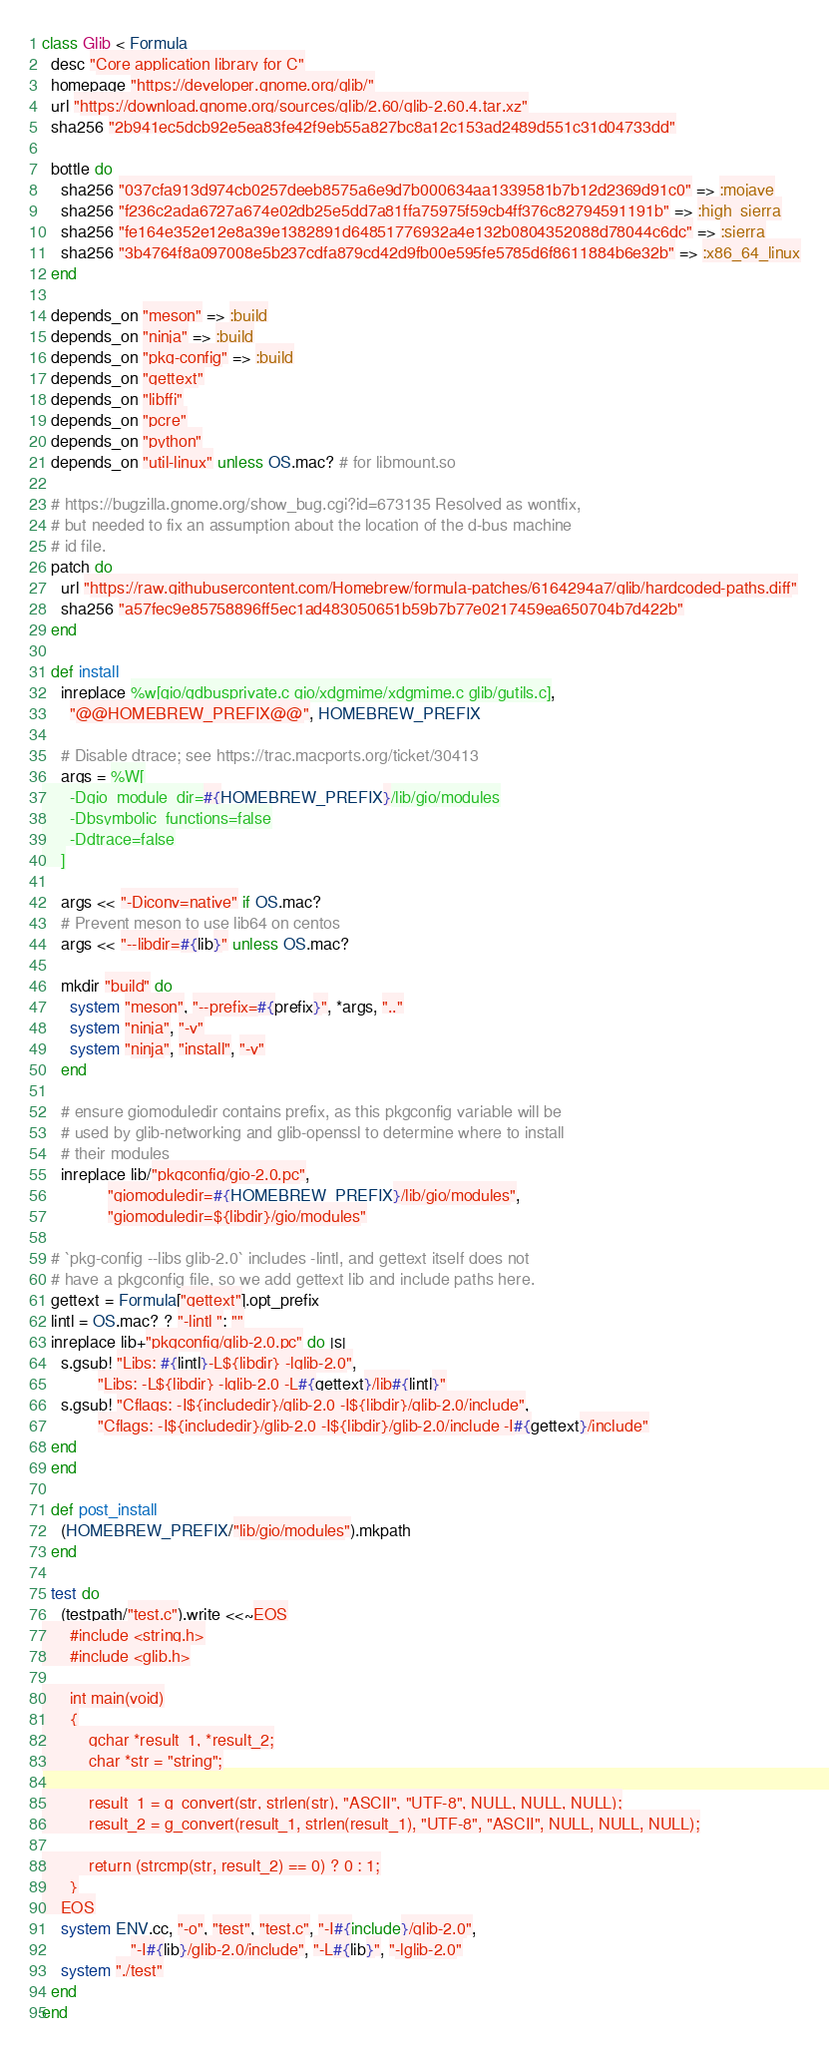<code> <loc_0><loc_0><loc_500><loc_500><_Ruby_>class Glib < Formula
  desc "Core application library for C"
  homepage "https://developer.gnome.org/glib/"
  url "https://download.gnome.org/sources/glib/2.60/glib-2.60.4.tar.xz"
  sha256 "2b941ec5dcb92e5ea83fe42f9eb55a827bc8a12c153ad2489d551c31d04733dd"

  bottle do
    sha256 "037cfa913d974cb0257deeb8575a6e9d7b000634aa1339581b7b12d2369d91c0" => :mojave
    sha256 "f236c2ada6727a674e02db25e5dd7a81ffa75975f59cb4ff376c82794591191b" => :high_sierra
    sha256 "fe164e352e12e8a39e1382891d64851776932a4e132b0804352088d78044c6dc" => :sierra
    sha256 "3b4764f8a097008e5b237cdfa879cd42d9fb00e595fe5785d6f8611884b6e32b" => :x86_64_linux
  end

  depends_on "meson" => :build
  depends_on "ninja" => :build
  depends_on "pkg-config" => :build
  depends_on "gettext"
  depends_on "libffi"
  depends_on "pcre"
  depends_on "python"
  depends_on "util-linux" unless OS.mac? # for libmount.so

  # https://bugzilla.gnome.org/show_bug.cgi?id=673135 Resolved as wontfix,
  # but needed to fix an assumption about the location of the d-bus machine
  # id file.
  patch do
    url "https://raw.githubusercontent.com/Homebrew/formula-patches/6164294a7/glib/hardcoded-paths.diff"
    sha256 "a57fec9e85758896ff5ec1ad483050651b59b7b77e0217459ea650704b7d422b"
  end

  def install
    inreplace %w[gio/gdbusprivate.c gio/xdgmime/xdgmime.c glib/gutils.c],
      "@@HOMEBREW_PREFIX@@", HOMEBREW_PREFIX

    # Disable dtrace; see https://trac.macports.org/ticket/30413
    args = %W[
      -Dgio_module_dir=#{HOMEBREW_PREFIX}/lib/gio/modules
      -Dbsymbolic_functions=false
      -Ddtrace=false
    ]

    args << "-Diconv=native" if OS.mac?
    # Prevent meson to use lib64 on centos
    args << "--libdir=#{lib}" unless OS.mac?

    mkdir "build" do
      system "meson", "--prefix=#{prefix}", *args, ".."
      system "ninja", "-v"
      system "ninja", "install", "-v"
    end

    # ensure giomoduledir contains prefix, as this pkgconfig variable will be
    # used by glib-networking and glib-openssl to determine where to install
    # their modules
    inreplace lib/"pkgconfig/gio-2.0.pc",
              "giomoduledir=#{HOMEBREW_PREFIX}/lib/gio/modules",
              "giomoduledir=${libdir}/gio/modules"

  # `pkg-config --libs glib-2.0` includes -lintl, and gettext itself does not
  # have a pkgconfig file, so we add gettext lib and include paths here.
  gettext = Formula["gettext"].opt_prefix
  lintl = OS.mac? ? "-lintl ": ""
  inreplace lib+"pkgconfig/glib-2.0.pc" do |s|
    s.gsub! "Libs: #{lintl}-L${libdir} -lglib-2.0",
            "Libs: -L${libdir} -lglib-2.0 -L#{gettext}/lib#{lintl}"
    s.gsub! "Cflags: -I${includedir}/glib-2.0 -I${libdir}/glib-2.0/include",
            "Cflags: -I${includedir}/glib-2.0 -I${libdir}/glib-2.0/include -I#{gettext}/include"
  end
  end

  def post_install
    (HOMEBREW_PREFIX/"lib/gio/modules").mkpath
  end

  test do
    (testpath/"test.c").write <<~EOS
      #include <string.h>
      #include <glib.h>

      int main(void)
      {
          gchar *result_1, *result_2;
          char *str = "string";

          result_1 = g_convert(str, strlen(str), "ASCII", "UTF-8", NULL, NULL, NULL);
          result_2 = g_convert(result_1, strlen(result_1), "UTF-8", "ASCII", NULL, NULL, NULL);

          return (strcmp(str, result_2) == 0) ? 0 : 1;
      }
    EOS
    system ENV.cc, "-o", "test", "test.c", "-I#{include}/glib-2.0",
                   "-I#{lib}/glib-2.0/include", "-L#{lib}", "-lglib-2.0"
    system "./test"
  end
end
</code> 